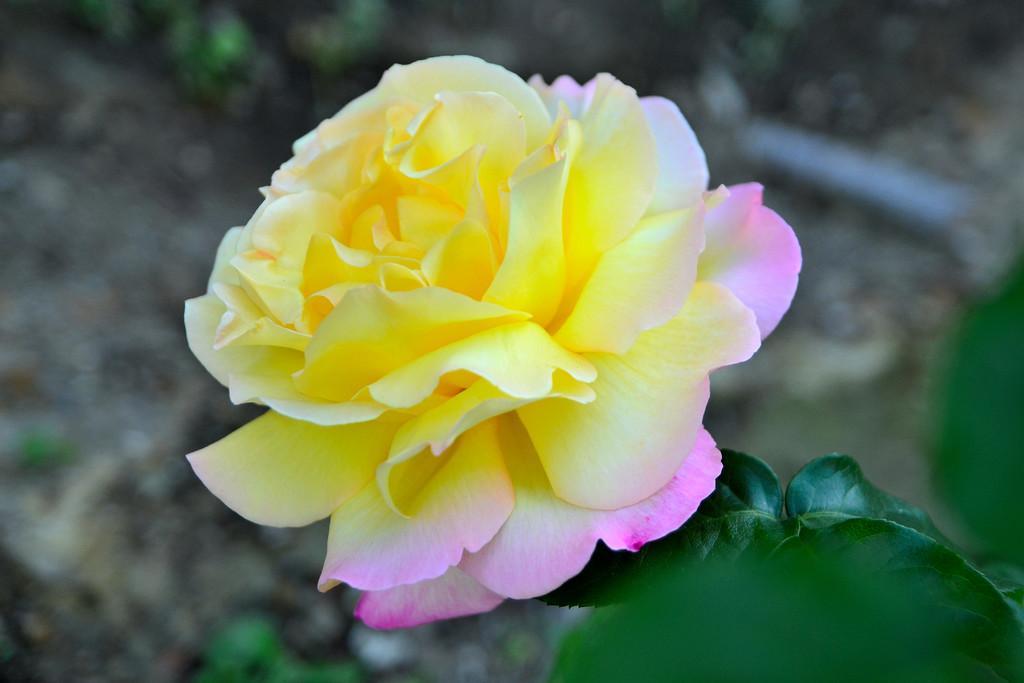How would you summarize this image in a sentence or two? In this picture there is a flower on the plant. At the back there is a plant. At the bottom there is mud and the flower is in yellow and pink color. 